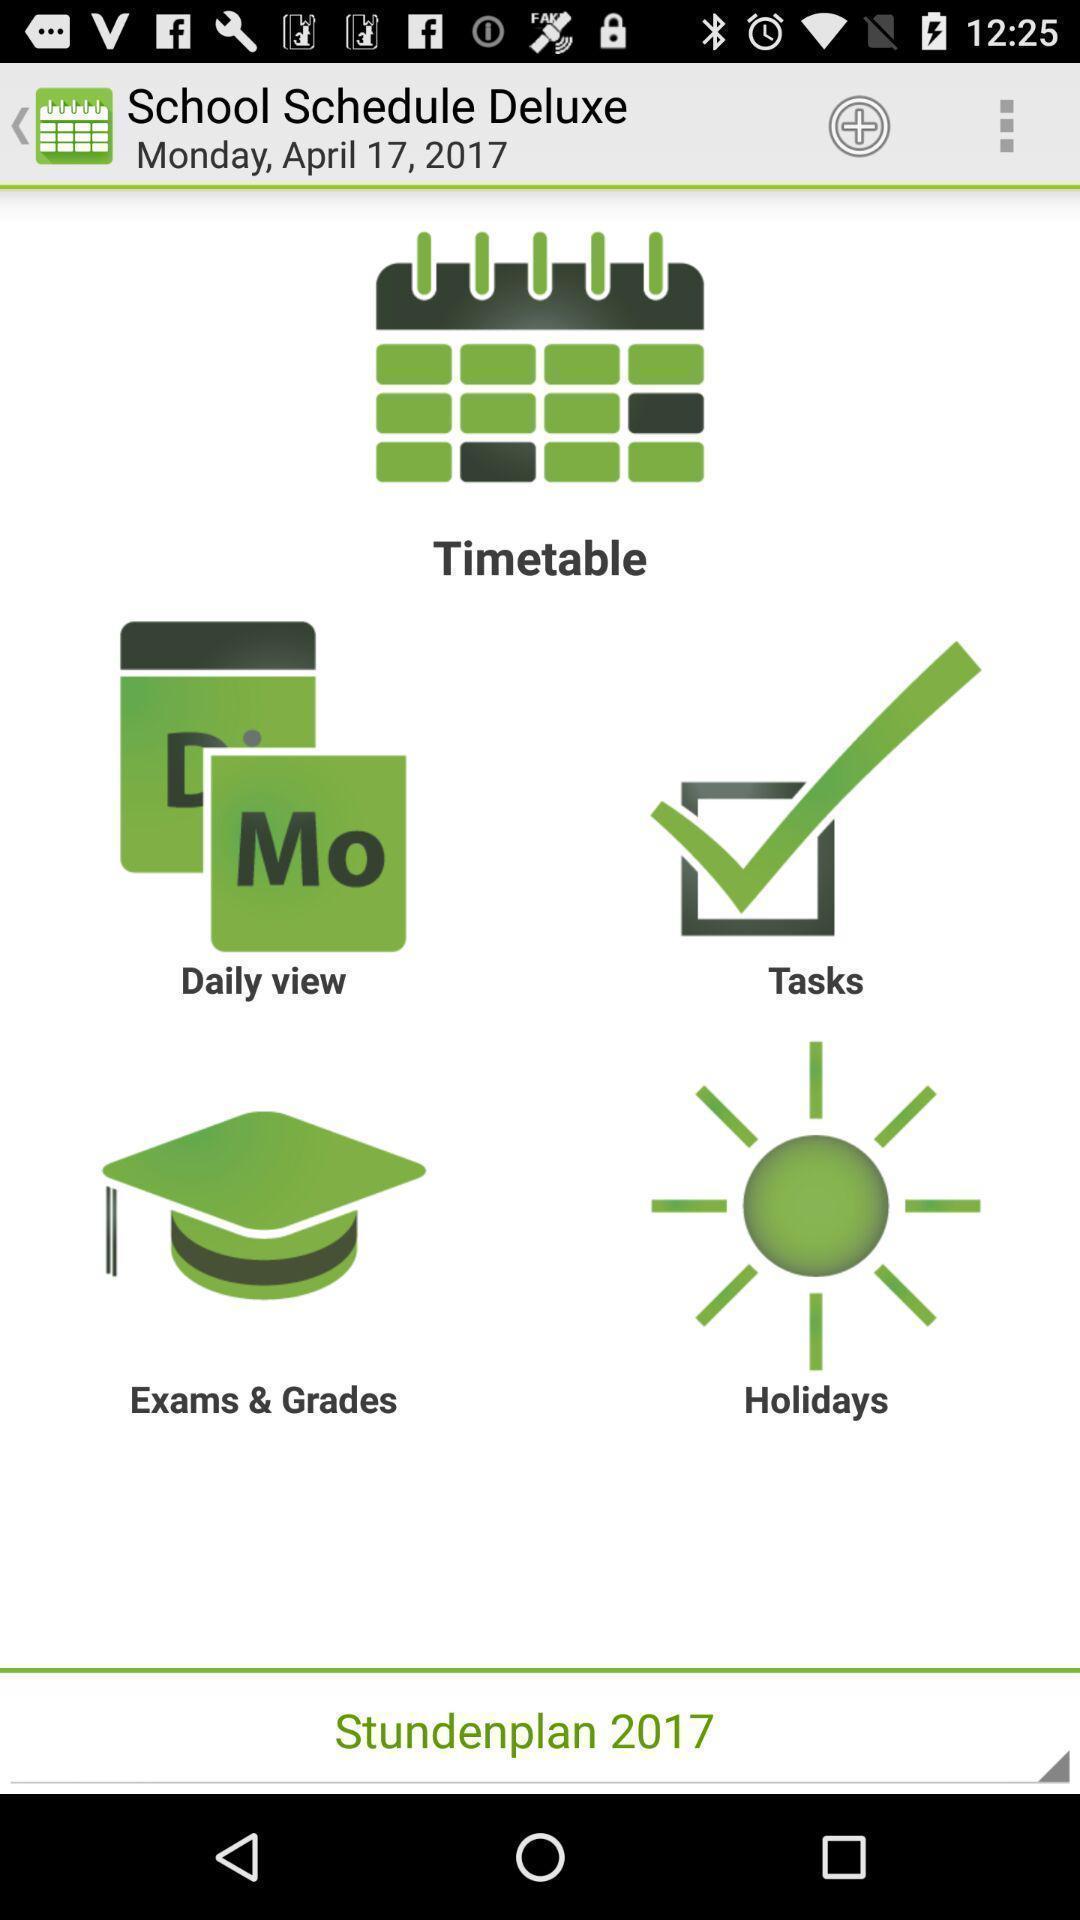Describe the key features of this screenshot. Screen showing list of multiple options in a study app. 